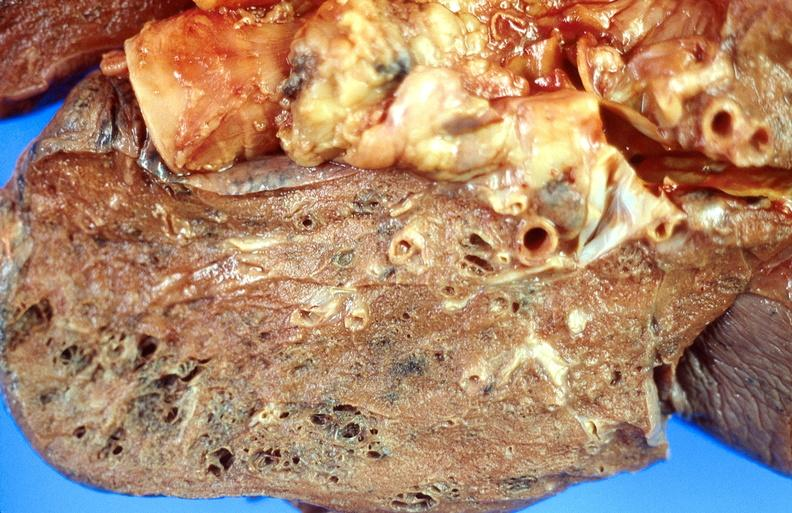s cervical carcinoma present?
Answer the question using a single word or phrase. No 